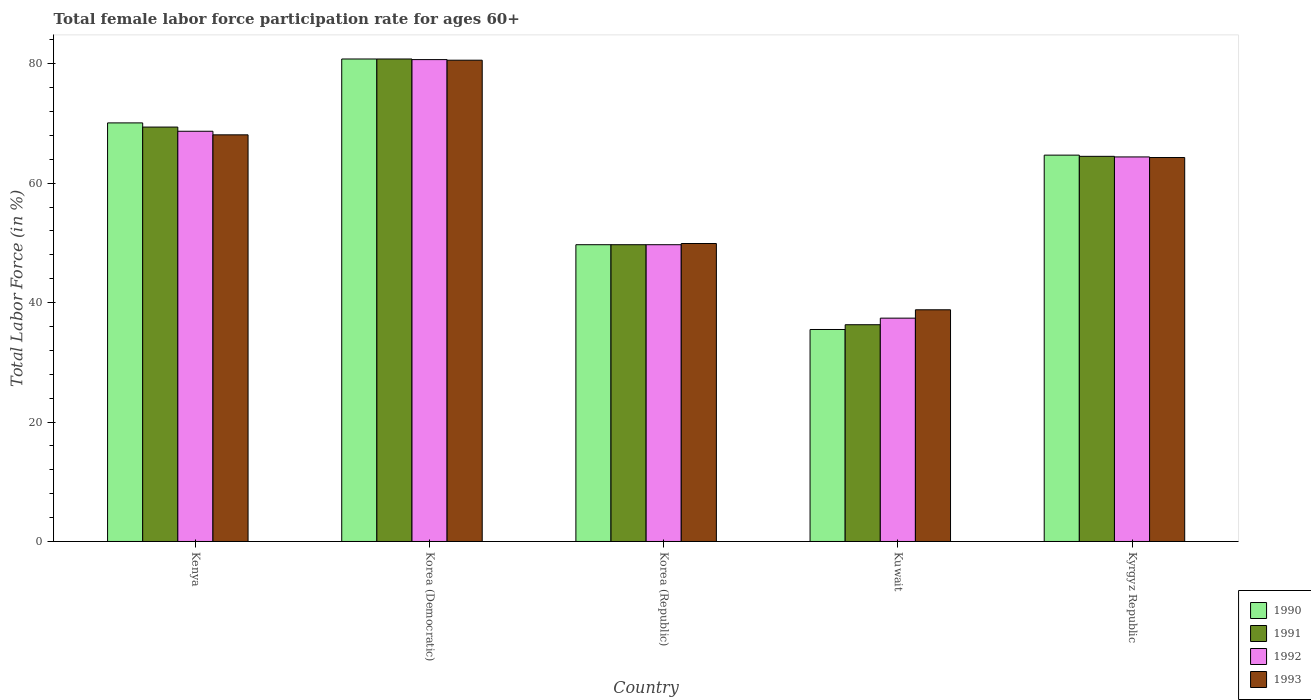Are the number of bars per tick equal to the number of legend labels?
Your response must be concise. Yes. Are the number of bars on each tick of the X-axis equal?
Provide a short and direct response. Yes. How many bars are there on the 5th tick from the left?
Make the answer very short. 4. How many bars are there on the 1st tick from the right?
Offer a very short reply. 4. What is the label of the 2nd group of bars from the left?
Your response must be concise. Korea (Democratic). What is the female labor force participation rate in 1990 in Korea (Republic)?
Offer a very short reply. 49.7. Across all countries, what is the maximum female labor force participation rate in 1993?
Your answer should be very brief. 80.6. Across all countries, what is the minimum female labor force participation rate in 1993?
Your response must be concise. 38.8. In which country was the female labor force participation rate in 1991 maximum?
Give a very brief answer. Korea (Democratic). In which country was the female labor force participation rate in 1992 minimum?
Offer a terse response. Kuwait. What is the total female labor force participation rate in 1992 in the graph?
Offer a terse response. 300.9. What is the difference between the female labor force participation rate in 1990 in Korea (Republic) and that in Kyrgyz Republic?
Your response must be concise. -15. What is the difference between the female labor force participation rate in 1990 in Kuwait and the female labor force participation rate in 1991 in Korea (Republic)?
Offer a terse response. -14.2. What is the average female labor force participation rate in 1993 per country?
Provide a short and direct response. 60.34. What is the difference between the female labor force participation rate of/in 1993 and female labor force participation rate of/in 1990 in Kyrgyz Republic?
Ensure brevity in your answer.  -0.4. In how many countries, is the female labor force participation rate in 1991 greater than 24 %?
Provide a short and direct response. 5. What is the ratio of the female labor force participation rate in 1990 in Korea (Republic) to that in Kyrgyz Republic?
Your answer should be very brief. 0.77. What is the difference between the highest and the second highest female labor force participation rate in 1990?
Make the answer very short. 16.1. What is the difference between the highest and the lowest female labor force participation rate in 1992?
Keep it short and to the point. 43.3. In how many countries, is the female labor force participation rate in 1990 greater than the average female labor force participation rate in 1990 taken over all countries?
Provide a short and direct response. 3. Is the sum of the female labor force participation rate in 1993 in Korea (Republic) and Kuwait greater than the maximum female labor force participation rate in 1990 across all countries?
Your response must be concise. Yes. Is it the case that in every country, the sum of the female labor force participation rate in 1993 and female labor force participation rate in 1990 is greater than the sum of female labor force participation rate in 1992 and female labor force participation rate in 1991?
Provide a short and direct response. No. What does the 4th bar from the right in Kuwait represents?
Ensure brevity in your answer.  1990. Is it the case that in every country, the sum of the female labor force participation rate in 1993 and female labor force participation rate in 1990 is greater than the female labor force participation rate in 1991?
Your answer should be compact. Yes. How many bars are there?
Keep it short and to the point. 20. Are all the bars in the graph horizontal?
Keep it short and to the point. No. How many countries are there in the graph?
Offer a very short reply. 5. What is the difference between two consecutive major ticks on the Y-axis?
Provide a succinct answer. 20. Are the values on the major ticks of Y-axis written in scientific E-notation?
Your answer should be compact. No. Does the graph contain any zero values?
Offer a terse response. No. Does the graph contain grids?
Ensure brevity in your answer.  No. What is the title of the graph?
Give a very brief answer. Total female labor force participation rate for ages 60+. What is the label or title of the X-axis?
Ensure brevity in your answer.  Country. What is the Total Labor Force (in %) of 1990 in Kenya?
Make the answer very short. 70.1. What is the Total Labor Force (in %) of 1991 in Kenya?
Keep it short and to the point. 69.4. What is the Total Labor Force (in %) of 1992 in Kenya?
Provide a short and direct response. 68.7. What is the Total Labor Force (in %) in 1993 in Kenya?
Your answer should be very brief. 68.1. What is the Total Labor Force (in %) of 1990 in Korea (Democratic)?
Your response must be concise. 80.8. What is the Total Labor Force (in %) in 1991 in Korea (Democratic)?
Keep it short and to the point. 80.8. What is the Total Labor Force (in %) in 1992 in Korea (Democratic)?
Make the answer very short. 80.7. What is the Total Labor Force (in %) in 1993 in Korea (Democratic)?
Provide a short and direct response. 80.6. What is the Total Labor Force (in %) of 1990 in Korea (Republic)?
Provide a short and direct response. 49.7. What is the Total Labor Force (in %) of 1991 in Korea (Republic)?
Make the answer very short. 49.7. What is the Total Labor Force (in %) of 1992 in Korea (Republic)?
Your answer should be very brief. 49.7. What is the Total Labor Force (in %) in 1993 in Korea (Republic)?
Make the answer very short. 49.9. What is the Total Labor Force (in %) of 1990 in Kuwait?
Give a very brief answer. 35.5. What is the Total Labor Force (in %) in 1991 in Kuwait?
Your response must be concise. 36.3. What is the Total Labor Force (in %) of 1992 in Kuwait?
Provide a succinct answer. 37.4. What is the Total Labor Force (in %) of 1993 in Kuwait?
Offer a very short reply. 38.8. What is the Total Labor Force (in %) of 1990 in Kyrgyz Republic?
Your answer should be very brief. 64.7. What is the Total Labor Force (in %) in 1991 in Kyrgyz Republic?
Your answer should be compact. 64.5. What is the Total Labor Force (in %) in 1992 in Kyrgyz Republic?
Give a very brief answer. 64.4. What is the Total Labor Force (in %) in 1993 in Kyrgyz Republic?
Give a very brief answer. 64.3. Across all countries, what is the maximum Total Labor Force (in %) of 1990?
Give a very brief answer. 80.8. Across all countries, what is the maximum Total Labor Force (in %) of 1991?
Make the answer very short. 80.8. Across all countries, what is the maximum Total Labor Force (in %) of 1992?
Offer a very short reply. 80.7. Across all countries, what is the maximum Total Labor Force (in %) of 1993?
Your response must be concise. 80.6. Across all countries, what is the minimum Total Labor Force (in %) in 1990?
Provide a short and direct response. 35.5. Across all countries, what is the minimum Total Labor Force (in %) of 1991?
Your response must be concise. 36.3. Across all countries, what is the minimum Total Labor Force (in %) in 1992?
Provide a succinct answer. 37.4. Across all countries, what is the minimum Total Labor Force (in %) of 1993?
Offer a terse response. 38.8. What is the total Total Labor Force (in %) in 1990 in the graph?
Your response must be concise. 300.8. What is the total Total Labor Force (in %) in 1991 in the graph?
Keep it short and to the point. 300.7. What is the total Total Labor Force (in %) in 1992 in the graph?
Your answer should be compact. 300.9. What is the total Total Labor Force (in %) of 1993 in the graph?
Your response must be concise. 301.7. What is the difference between the Total Labor Force (in %) in 1990 in Kenya and that in Korea (Democratic)?
Offer a terse response. -10.7. What is the difference between the Total Labor Force (in %) of 1992 in Kenya and that in Korea (Democratic)?
Offer a very short reply. -12. What is the difference between the Total Labor Force (in %) in 1990 in Kenya and that in Korea (Republic)?
Ensure brevity in your answer.  20.4. What is the difference between the Total Labor Force (in %) of 1993 in Kenya and that in Korea (Republic)?
Offer a terse response. 18.2. What is the difference between the Total Labor Force (in %) in 1990 in Kenya and that in Kuwait?
Give a very brief answer. 34.6. What is the difference between the Total Labor Force (in %) of 1991 in Kenya and that in Kuwait?
Give a very brief answer. 33.1. What is the difference between the Total Labor Force (in %) of 1992 in Kenya and that in Kuwait?
Ensure brevity in your answer.  31.3. What is the difference between the Total Labor Force (in %) of 1993 in Kenya and that in Kuwait?
Make the answer very short. 29.3. What is the difference between the Total Labor Force (in %) in 1990 in Kenya and that in Kyrgyz Republic?
Provide a succinct answer. 5.4. What is the difference between the Total Labor Force (in %) in 1991 in Kenya and that in Kyrgyz Republic?
Your response must be concise. 4.9. What is the difference between the Total Labor Force (in %) in 1990 in Korea (Democratic) and that in Korea (Republic)?
Offer a terse response. 31.1. What is the difference between the Total Labor Force (in %) of 1991 in Korea (Democratic) and that in Korea (Republic)?
Your answer should be very brief. 31.1. What is the difference between the Total Labor Force (in %) in 1992 in Korea (Democratic) and that in Korea (Republic)?
Your answer should be compact. 31. What is the difference between the Total Labor Force (in %) of 1993 in Korea (Democratic) and that in Korea (Republic)?
Your answer should be very brief. 30.7. What is the difference between the Total Labor Force (in %) in 1990 in Korea (Democratic) and that in Kuwait?
Your response must be concise. 45.3. What is the difference between the Total Labor Force (in %) of 1991 in Korea (Democratic) and that in Kuwait?
Offer a terse response. 44.5. What is the difference between the Total Labor Force (in %) in 1992 in Korea (Democratic) and that in Kuwait?
Give a very brief answer. 43.3. What is the difference between the Total Labor Force (in %) in 1993 in Korea (Democratic) and that in Kuwait?
Provide a succinct answer. 41.8. What is the difference between the Total Labor Force (in %) of 1991 in Korea (Democratic) and that in Kyrgyz Republic?
Give a very brief answer. 16.3. What is the difference between the Total Labor Force (in %) in 1992 in Korea (Democratic) and that in Kyrgyz Republic?
Provide a short and direct response. 16.3. What is the difference between the Total Labor Force (in %) in 1991 in Korea (Republic) and that in Kuwait?
Your response must be concise. 13.4. What is the difference between the Total Labor Force (in %) in 1993 in Korea (Republic) and that in Kuwait?
Offer a terse response. 11.1. What is the difference between the Total Labor Force (in %) of 1991 in Korea (Republic) and that in Kyrgyz Republic?
Offer a very short reply. -14.8. What is the difference between the Total Labor Force (in %) of 1992 in Korea (Republic) and that in Kyrgyz Republic?
Your response must be concise. -14.7. What is the difference between the Total Labor Force (in %) of 1993 in Korea (Republic) and that in Kyrgyz Republic?
Provide a short and direct response. -14.4. What is the difference between the Total Labor Force (in %) of 1990 in Kuwait and that in Kyrgyz Republic?
Make the answer very short. -29.2. What is the difference between the Total Labor Force (in %) in 1991 in Kuwait and that in Kyrgyz Republic?
Provide a short and direct response. -28.2. What is the difference between the Total Labor Force (in %) of 1993 in Kuwait and that in Kyrgyz Republic?
Make the answer very short. -25.5. What is the difference between the Total Labor Force (in %) in 1990 in Kenya and the Total Labor Force (in %) in 1991 in Korea (Democratic)?
Your answer should be very brief. -10.7. What is the difference between the Total Labor Force (in %) of 1991 in Kenya and the Total Labor Force (in %) of 1992 in Korea (Democratic)?
Your answer should be very brief. -11.3. What is the difference between the Total Labor Force (in %) of 1991 in Kenya and the Total Labor Force (in %) of 1993 in Korea (Democratic)?
Provide a short and direct response. -11.2. What is the difference between the Total Labor Force (in %) in 1992 in Kenya and the Total Labor Force (in %) in 1993 in Korea (Democratic)?
Keep it short and to the point. -11.9. What is the difference between the Total Labor Force (in %) in 1990 in Kenya and the Total Labor Force (in %) in 1991 in Korea (Republic)?
Your answer should be compact. 20.4. What is the difference between the Total Labor Force (in %) of 1990 in Kenya and the Total Labor Force (in %) of 1992 in Korea (Republic)?
Give a very brief answer. 20.4. What is the difference between the Total Labor Force (in %) of 1990 in Kenya and the Total Labor Force (in %) of 1993 in Korea (Republic)?
Ensure brevity in your answer.  20.2. What is the difference between the Total Labor Force (in %) in 1991 in Kenya and the Total Labor Force (in %) in 1993 in Korea (Republic)?
Provide a succinct answer. 19.5. What is the difference between the Total Labor Force (in %) in 1992 in Kenya and the Total Labor Force (in %) in 1993 in Korea (Republic)?
Your answer should be compact. 18.8. What is the difference between the Total Labor Force (in %) of 1990 in Kenya and the Total Labor Force (in %) of 1991 in Kuwait?
Keep it short and to the point. 33.8. What is the difference between the Total Labor Force (in %) in 1990 in Kenya and the Total Labor Force (in %) in 1992 in Kuwait?
Make the answer very short. 32.7. What is the difference between the Total Labor Force (in %) of 1990 in Kenya and the Total Labor Force (in %) of 1993 in Kuwait?
Make the answer very short. 31.3. What is the difference between the Total Labor Force (in %) in 1991 in Kenya and the Total Labor Force (in %) in 1993 in Kuwait?
Your answer should be very brief. 30.6. What is the difference between the Total Labor Force (in %) of 1992 in Kenya and the Total Labor Force (in %) of 1993 in Kuwait?
Offer a terse response. 29.9. What is the difference between the Total Labor Force (in %) of 1990 in Kenya and the Total Labor Force (in %) of 1991 in Kyrgyz Republic?
Make the answer very short. 5.6. What is the difference between the Total Labor Force (in %) of 1990 in Kenya and the Total Labor Force (in %) of 1992 in Kyrgyz Republic?
Keep it short and to the point. 5.7. What is the difference between the Total Labor Force (in %) of 1990 in Kenya and the Total Labor Force (in %) of 1993 in Kyrgyz Republic?
Your answer should be very brief. 5.8. What is the difference between the Total Labor Force (in %) of 1991 in Kenya and the Total Labor Force (in %) of 1992 in Kyrgyz Republic?
Ensure brevity in your answer.  5. What is the difference between the Total Labor Force (in %) of 1991 in Kenya and the Total Labor Force (in %) of 1993 in Kyrgyz Republic?
Give a very brief answer. 5.1. What is the difference between the Total Labor Force (in %) in 1992 in Kenya and the Total Labor Force (in %) in 1993 in Kyrgyz Republic?
Ensure brevity in your answer.  4.4. What is the difference between the Total Labor Force (in %) of 1990 in Korea (Democratic) and the Total Labor Force (in %) of 1991 in Korea (Republic)?
Provide a succinct answer. 31.1. What is the difference between the Total Labor Force (in %) of 1990 in Korea (Democratic) and the Total Labor Force (in %) of 1992 in Korea (Republic)?
Your response must be concise. 31.1. What is the difference between the Total Labor Force (in %) of 1990 in Korea (Democratic) and the Total Labor Force (in %) of 1993 in Korea (Republic)?
Keep it short and to the point. 30.9. What is the difference between the Total Labor Force (in %) in 1991 in Korea (Democratic) and the Total Labor Force (in %) in 1992 in Korea (Republic)?
Keep it short and to the point. 31.1. What is the difference between the Total Labor Force (in %) of 1991 in Korea (Democratic) and the Total Labor Force (in %) of 1993 in Korea (Republic)?
Give a very brief answer. 30.9. What is the difference between the Total Labor Force (in %) of 1992 in Korea (Democratic) and the Total Labor Force (in %) of 1993 in Korea (Republic)?
Provide a succinct answer. 30.8. What is the difference between the Total Labor Force (in %) in 1990 in Korea (Democratic) and the Total Labor Force (in %) in 1991 in Kuwait?
Your response must be concise. 44.5. What is the difference between the Total Labor Force (in %) of 1990 in Korea (Democratic) and the Total Labor Force (in %) of 1992 in Kuwait?
Provide a succinct answer. 43.4. What is the difference between the Total Labor Force (in %) of 1991 in Korea (Democratic) and the Total Labor Force (in %) of 1992 in Kuwait?
Offer a very short reply. 43.4. What is the difference between the Total Labor Force (in %) of 1992 in Korea (Democratic) and the Total Labor Force (in %) of 1993 in Kuwait?
Your answer should be very brief. 41.9. What is the difference between the Total Labor Force (in %) in 1990 in Korea (Republic) and the Total Labor Force (in %) in 1991 in Kuwait?
Offer a terse response. 13.4. What is the difference between the Total Labor Force (in %) in 1990 in Korea (Republic) and the Total Labor Force (in %) in 1992 in Kuwait?
Offer a very short reply. 12.3. What is the difference between the Total Labor Force (in %) of 1990 in Korea (Republic) and the Total Labor Force (in %) of 1993 in Kuwait?
Give a very brief answer. 10.9. What is the difference between the Total Labor Force (in %) of 1992 in Korea (Republic) and the Total Labor Force (in %) of 1993 in Kuwait?
Provide a short and direct response. 10.9. What is the difference between the Total Labor Force (in %) of 1990 in Korea (Republic) and the Total Labor Force (in %) of 1991 in Kyrgyz Republic?
Your response must be concise. -14.8. What is the difference between the Total Labor Force (in %) of 1990 in Korea (Republic) and the Total Labor Force (in %) of 1992 in Kyrgyz Republic?
Ensure brevity in your answer.  -14.7. What is the difference between the Total Labor Force (in %) of 1990 in Korea (Republic) and the Total Labor Force (in %) of 1993 in Kyrgyz Republic?
Provide a succinct answer. -14.6. What is the difference between the Total Labor Force (in %) of 1991 in Korea (Republic) and the Total Labor Force (in %) of 1992 in Kyrgyz Republic?
Provide a succinct answer. -14.7. What is the difference between the Total Labor Force (in %) of 1991 in Korea (Republic) and the Total Labor Force (in %) of 1993 in Kyrgyz Republic?
Offer a very short reply. -14.6. What is the difference between the Total Labor Force (in %) of 1992 in Korea (Republic) and the Total Labor Force (in %) of 1993 in Kyrgyz Republic?
Provide a succinct answer. -14.6. What is the difference between the Total Labor Force (in %) of 1990 in Kuwait and the Total Labor Force (in %) of 1992 in Kyrgyz Republic?
Your response must be concise. -28.9. What is the difference between the Total Labor Force (in %) in 1990 in Kuwait and the Total Labor Force (in %) in 1993 in Kyrgyz Republic?
Make the answer very short. -28.8. What is the difference between the Total Labor Force (in %) in 1991 in Kuwait and the Total Labor Force (in %) in 1992 in Kyrgyz Republic?
Provide a succinct answer. -28.1. What is the difference between the Total Labor Force (in %) of 1991 in Kuwait and the Total Labor Force (in %) of 1993 in Kyrgyz Republic?
Your response must be concise. -28. What is the difference between the Total Labor Force (in %) in 1992 in Kuwait and the Total Labor Force (in %) in 1993 in Kyrgyz Republic?
Ensure brevity in your answer.  -26.9. What is the average Total Labor Force (in %) of 1990 per country?
Ensure brevity in your answer.  60.16. What is the average Total Labor Force (in %) in 1991 per country?
Offer a very short reply. 60.14. What is the average Total Labor Force (in %) of 1992 per country?
Provide a succinct answer. 60.18. What is the average Total Labor Force (in %) of 1993 per country?
Give a very brief answer. 60.34. What is the difference between the Total Labor Force (in %) in 1991 and Total Labor Force (in %) in 1993 in Kenya?
Your answer should be compact. 1.3. What is the difference between the Total Labor Force (in %) in 1990 and Total Labor Force (in %) in 1992 in Korea (Democratic)?
Keep it short and to the point. 0.1. What is the difference between the Total Labor Force (in %) of 1991 and Total Labor Force (in %) of 1992 in Korea (Democratic)?
Give a very brief answer. 0.1. What is the difference between the Total Labor Force (in %) in 1991 and Total Labor Force (in %) in 1993 in Korea (Democratic)?
Offer a terse response. 0.2. What is the difference between the Total Labor Force (in %) in 1990 and Total Labor Force (in %) in 1991 in Korea (Republic)?
Give a very brief answer. 0. What is the difference between the Total Labor Force (in %) in 1990 and Total Labor Force (in %) in 1992 in Korea (Republic)?
Your response must be concise. 0. What is the difference between the Total Labor Force (in %) in 1990 and Total Labor Force (in %) in 1993 in Korea (Republic)?
Your answer should be very brief. -0.2. What is the difference between the Total Labor Force (in %) of 1991 and Total Labor Force (in %) of 1992 in Korea (Republic)?
Provide a succinct answer. 0. What is the difference between the Total Labor Force (in %) of 1991 and Total Labor Force (in %) of 1993 in Korea (Republic)?
Provide a short and direct response. -0.2. What is the difference between the Total Labor Force (in %) in 1992 and Total Labor Force (in %) in 1993 in Korea (Republic)?
Provide a succinct answer. -0.2. What is the difference between the Total Labor Force (in %) in 1990 and Total Labor Force (in %) in 1992 in Kuwait?
Give a very brief answer. -1.9. What is the difference between the Total Labor Force (in %) in 1990 and Total Labor Force (in %) in 1993 in Kuwait?
Make the answer very short. -3.3. What is the difference between the Total Labor Force (in %) of 1991 and Total Labor Force (in %) of 1993 in Kuwait?
Give a very brief answer. -2.5. What is the difference between the Total Labor Force (in %) in 1992 and Total Labor Force (in %) in 1993 in Kuwait?
Your response must be concise. -1.4. What is the difference between the Total Labor Force (in %) in 1990 and Total Labor Force (in %) in 1991 in Kyrgyz Republic?
Your answer should be compact. 0.2. What is the difference between the Total Labor Force (in %) in 1991 and Total Labor Force (in %) in 1992 in Kyrgyz Republic?
Give a very brief answer. 0.1. What is the ratio of the Total Labor Force (in %) of 1990 in Kenya to that in Korea (Democratic)?
Keep it short and to the point. 0.87. What is the ratio of the Total Labor Force (in %) in 1991 in Kenya to that in Korea (Democratic)?
Keep it short and to the point. 0.86. What is the ratio of the Total Labor Force (in %) of 1992 in Kenya to that in Korea (Democratic)?
Your response must be concise. 0.85. What is the ratio of the Total Labor Force (in %) of 1993 in Kenya to that in Korea (Democratic)?
Keep it short and to the point. 0.84. What is the ratio of the Total Labor Force (in %) of 1990 in Kenya to that in Korea (Republic)?
Your answer should be compact. 1.41. What is the ratio of the Total Labor Force (in %) in 1991 in Kenya to that in Korea (Republic)?
Make the answer very short. 1.4. What is the ratio of the Total Labor Force (in %) in 1992 in Kenya to that in Korea (Republic)?
Ensure brevity in your answer.  1.38. What is the ratio of the Total Labor Force (in %) in 1993 in Kenya to that in Korea (Republic)?
Give a very brief answer. 1.36. What is the ratio of the Total Labor Force (in %) in 1990 in Kenya to that in Kuwait?
Your response must be concise. 1.97. What is the ratio of the Total Labor Force (in %) in 1991 in Kenya to that in Kuwait?
Your answer should be very brief. 1.91. What is the ratio of the Total Labor Force (in %) in 1992 in Kenya to that in Kuwait?
Your answer should be very brief. 1.84. What is the ratio of the Total Labor Force (in %) of 1993 in Kenya to that in Kuwait?
Offer a very short reply. 1.76. What is the ratio of the Total Labor Force (in %) of 1990 in Kenya to that in Kyrgyz Republic?
Provide a short and direct response. 1.08. What is the ratio of the Total Labor Force (in %) in 1991 in Kenya to that in Kyrgyz Republic?
Make the answer very short. 1.08. What is the ratio of the Total Labor Force (in %) in 1992 in Kenya to that in Kyrgyz Republic?
Your response must be concise. 1.07. What is the ratio of the Total Labor Force (in %) of 1993 in Kenya to that in Kyrgyz Republic?
Provide a short and direct response. 1.06. What is the ratio of the Total Labor Force (in %) of 1990 in Korea (Democratic) to that in Korea (Republic)?
Offer a terse response. 1.63. What is the ratio of the Total Labor Force (in %) in 1991 in Korea (Democratic) to that in Korea (Republic)?
Give a very brief answer. 1.63. What is the ratio of the Total Labor Force (in %) in 1992 in Korea (Democratic) to that in Korea (Republic)?
Your answer should be compact. 1.62. What is the ratio of the Total Labor Force (in %) of 1993 in Korea (Democratic) to that in Korea (Republic)?
Your answer should be compact. 1.62. What is the ratio of the Total Labor Force (in %) in 1990 in Korea (Democratic) to that in Kuwait?
Ensure brevity in your answer.  2.28. What is the ratio of the Total Labor Force (in %) in 1991 in Korea (Democratic) to that in Kuwait?
Offer a terse response. 2.23. What is the ratio of the Total Labor Force (in %) of 1992 in Korea (Democratic) to that in Kuwait?
Your answer should be very brief. 2.16. What is the ratio of the Total Labor Force (in %) in 1993 in Korea (Democratic) to that in Kuwait?
Provide a succinct answer. 2.08. What is the ratio of the Total Labor Force (in %) of 1990 in Korea (Democratic) to that in Kyrgyz Republic?
Offer a terse response. 1.25. What is the ratio of the Total Labor Force (in %) of 1991 in Korea (Democratic) to that in Kyrgyz Republic?
Make the answer very short. 1.25. What is the ratio of the Total Labor Force (in %) of 1992 in Korea (Democratic) to that in Kyrgyz Republic?
Make the answer very short. 1.25. What is the ratio of the Total Labor Force (in %) in 1993 in Korea (Democratic) to that in Kyrgyz Republic?
Keep it short and to the point. 1.25. What is the ratio of the Total Labor Force (in %) in 1990 in Korea (Republic) to that in Kuwait?
Your answer should be very brief. 1.4. What is the ratio of the Total Labor Force (in %) of 1991 in Korea (Republic) to that in Kuwait?
Your answer should be very brief. 1.37. What is the ratio of the Total Labor Force (in %) of 1992 in Korea (Republic) to that in Kuwait?
Ensure brevity in your answer.  1.33. What is the ratio of the Total Labor Force (in %) in 1993 in Korea (Republic) to that in Kuwait?
Keep it short and to the point. 1.29. What is the ratio of the Total Labor Force (in %) in 1990 in Korea (Republic) to that in Kyrgyz Republic?
Give a very brief answer. 0.77. What is the ratio of the Total Labor Force (in %) of 1991 in Korea (Republic) to that in Kyrgyz Republic?
Offer a very short reply. 0.77. What is the ratio of the Total Labor Force (in %) in 1992 in Korea (Republic) to that in Kyrgyz Republic?
Ensure brevity in your answer.  0.77. What is the ratio of the Total Labor Force (in %) in 1993 in Korea (Republic) to that in Kyrgyz Republic?
Provide a short and direct response. 0.78. What is the ratio of the Total Labor Force (in %) in 1990 in Kuwait to that in Kyrgyz Republic?
Ensure brevity in your answer.  0.55. What is the ratio of the Total Labor Force (in %) in 1991 in Kuwait to that in Kyrgyz Republic?
Keep it short and to the point. 0.56. What is the ratio of the Total Labor Force (in %) in 1992 in Kuwait to that in Kyrgyz Republic?
Ensure brevity in your answer.  0.58. What is the ratio of the Total Labor Force (in %) of 1993 in Kuwait to that in Kyrgyz Republic?
Your answer should be very brief. 0.6. What is the difference between the highest and the lowest Total Labor Force (in %) in 1990?
Provide a short and direct response. 45.3. What is the difference between the highest and the lowest Total Labor Force (in %) of 1991?
Offer a terse response. 44.5. What is the difference between the highest and the lowest Total Labor Force (in %) in 1992?
Make the answer very short. 43.3. What is the difference between the highest and the lowest Total Labor Force (in %) of 1993?
Make the answer very short. 41.8. 